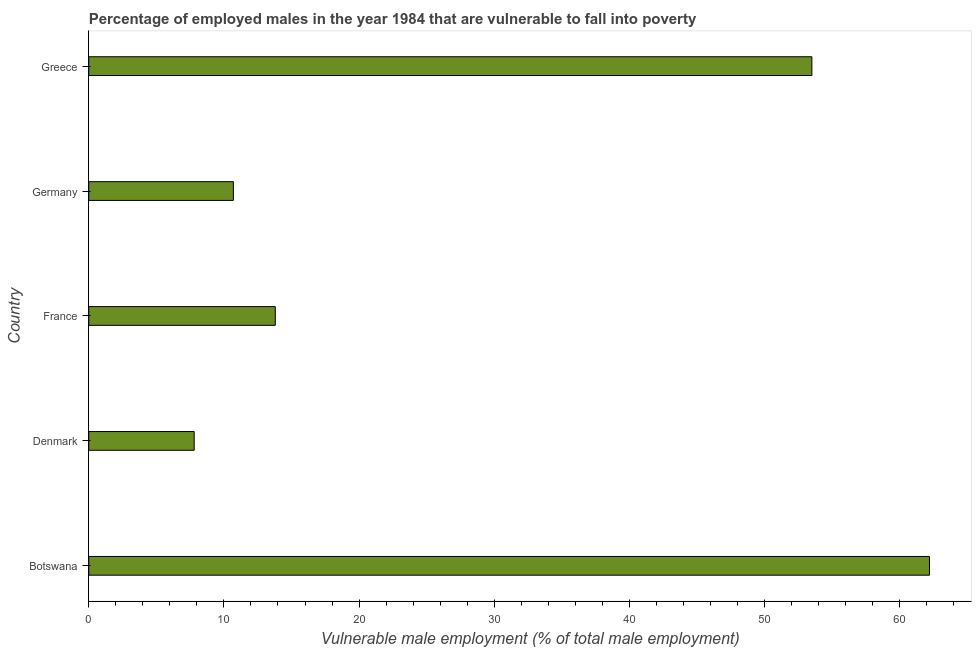Does the graph contain any zero values?
Provide a succinct answer. No. What is the title of the graph?
Provide a succinct answer. Percentage of employed males in the year 1984 that are vulnerable to fall into poverty. What is the label or title of the X-axis?
Make the answer very short. Vulnerable male employment (% of total male employment). What is the percentage of employed males who are vulnerable to fall into poverty in Greece?
Keep it short and to the point. 53.5. Across all countries, what is the maximum percentage of employed males who are vulnerable to fall into poverty?
Offer a terse response. 62.2. Across all countries, what is the minimum percentage of employed males who are vulnerable to fall into poverty?
Your answer should be compact. 7.8. In which country was the percentage of employed males who are vulnerable to fall into poverty maximum?
Offer a terse response. Botswana. What is the sum of the percentage of employed males who are vulnerable to fall into poverty?
Your answer should be compact. 148. What is the difference between the percentage of employed males who are vulnerable to fall into poverty in Botswana and Greece?
Offer a very short reply. 8.7. What is the average percentage of employed males who are vulnerable to fall into poverty per country?
Ensure brevity in your answer.  29.6. What is the median percentage of employed males who are vulnerable to fall into poverty?
Give a very brief answer. 13.8. In how many countries, is the percentage of employed males who are vulnerable to fall into poverty greater than 34 %?
Your answer should be compact. 2. What is the ratio of the percentage of employed males who are vulnerable to fall into poverty in Botswana to that in Denmark?
Your answer should be compact. 7.97. Is the percentage of employed males who are vulnerable to fall into poverty in Botswana less than that in Germany?
Offer a very short reply. No. What is the difference between the highest and the second highest percentage of employed males who are vulnerable to fall into poverty?
Your response must be concise. 8.7. What is the difference between the highest and the lowest percentage of employed males who are vulnerable to fall into poverty?
Offer a very short reply. 54.4. In how many countries, is the percentage of employed males who are vulnerable to fall into poverty greater than the average percentage of employed males who are vulnerable to fall into poverty taken over all countries?
Offer a very short reply. 2. Are the values on the major ticks of X-axis written in scientific E-notation?
Ensure brevity in your answer.  No. What is the Vulnerable male employment (% of total male employment) in Botswana?
Make the answer very short. 62.2. What is the Vulnerable male employment (% of total male employment) of Denmark?
Provide a succinct answer. 7.8. What is the Vulnerable male employment (% of total male employment) of France?
Offer a terse response. 13.8. What is the Vulnerable male employment (% of total male employment) in Germany?
Your answer should be very brief. 10.7. What is the Vulnerable male employment (% of total male employment) of Greece?
Offer a terse response. 53.5. What is the difference between the Vulnerable male employment (% of total male employment) in Botswana and Denmark?
Your answer should be compact. 54.4. What is the difference between the Vulnerable male employment (% of total male employment) in Botswana and France?
Offer a very short reply. 48.4. What is the difference between the Vulnerable male employment (% of total male employment) in Botswana and Germany?
Provide a short and direct response. 51.5. What is the difference between the Vulnerable male employment (% of total male employment) in Denmark and Germany?
Offer a terse response. -2.9. What is the difference between the Vulnerable male employment (% of total male employment) in Denmark and Greece?
Your answer should be very brief. -45.7. What is the difference between the Vulnerable male employment (% of total male employment) in France and Greece?
Offer a very short reply. -39.7. What is the difference between the Vulnerable male employment (% of total male employment) in Germany and Greece?
Your answer should be very brief. -42.8. What is the ratio of the Vulnerable male employment (% of total male employment) in Botswana to that in Denmark?
Your response must be concise. 7.97. What is the ratio of the Vulnerable male employment (% of total male employment) in Botswana to that in France?
Your answer should be very brief. 4.51. What is the ratio of the Vulnerable male employment (% of total male employment) in Botswana to that in Germany?
Give a very brief answer. 5.81. What is the ratio of the Vulnerable male employment (% of total male employment) in Botswana to that in Greece?
Provide a succinct answer. 1.16. What is the ratio of the Vulnerable male employment (% of total male employment) in Denmark to that in France?
Your answer should be very brief. 0.56. What is the ratio of the Vulnerable male employment (% of total male employment) in Denmark to that in Germany?
Offer a terse response. 0.73. What is the ratio of the Vulnerable male employment (% of total male employment) in Denmark to that in Greece?
Your response must be concise. 0.15. What is the ratio of the Vulnerable male employment (% of total male employment) in France to that in Germany?
Your response must be concise. 1.29. What is the ratio of the Vulnerable male employment (% of total male employment) in France to that in Greece?
Provide a short and direct response. 0.26. 